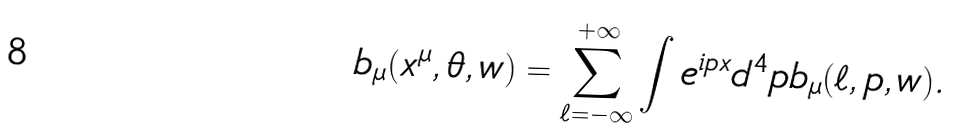<formula> <loc_0><loc_0><loc_500><loc_500>b _ { \mu } ( x ^ { \mu } , \theta , w ) = \sum _ { \ell = - \infty } ^ { + \infty } \int e ^ { i p x } d ^ { 4 } p b _ { \mu } ( \ell , p , w ) .</formula> 